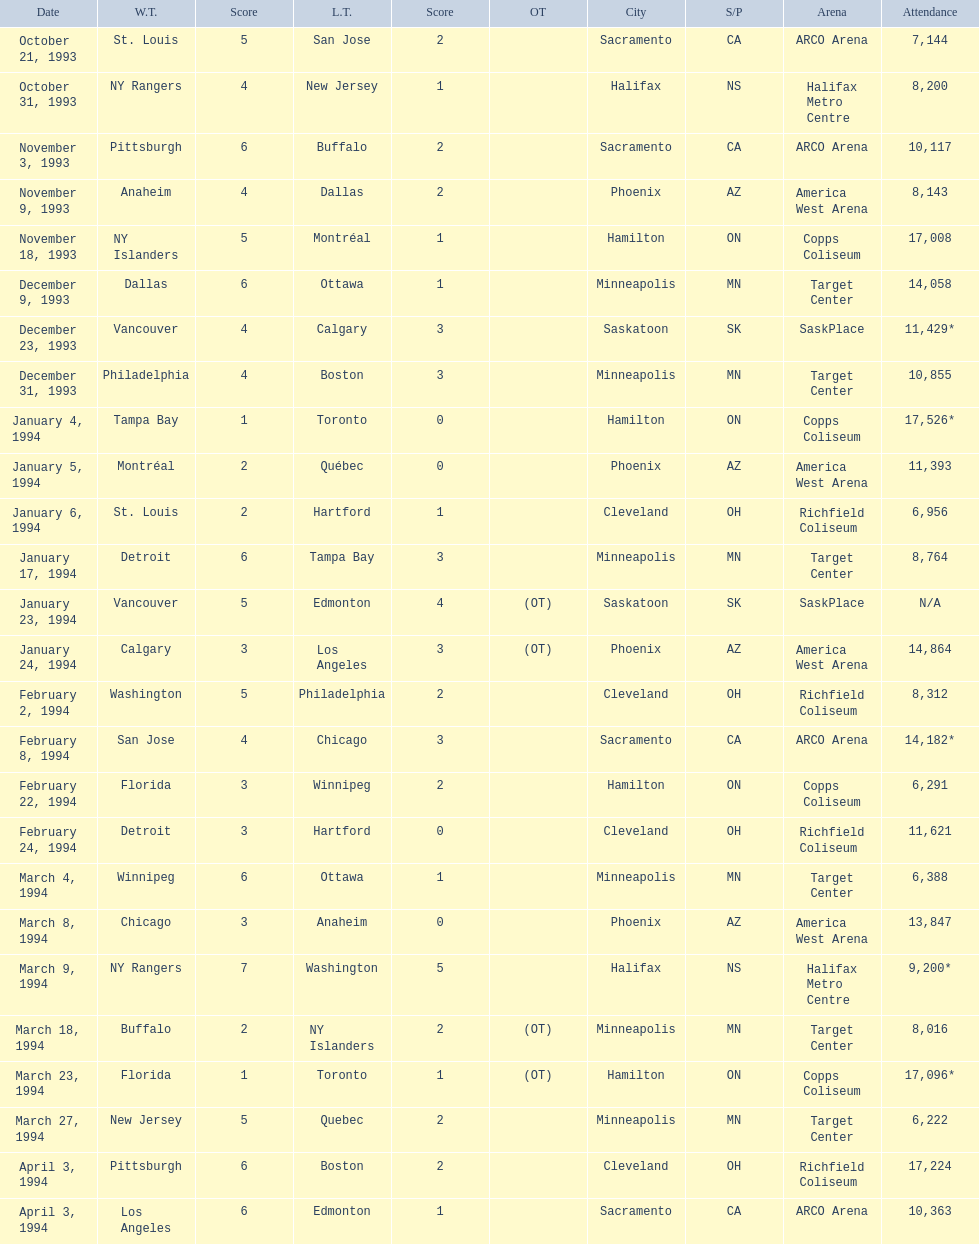What are the attendances of the 1993-94 nhl season? 7,144, 8,200, 10,117, 8,143, 17,008, 14,058, 11,429*, 10,855, 17,526*, 11,393, 6,956, 8,764, N/A, 14,864, 8,312, 14,182*, 6,291, 11,621, 6,388, 13,847, 9,200*, 8,016, 17,096*, 6,222, 17,224, 10,363. Which of these is the highest attendance? 17,526*. Which date did this attendance occur? January 4, 1994. 